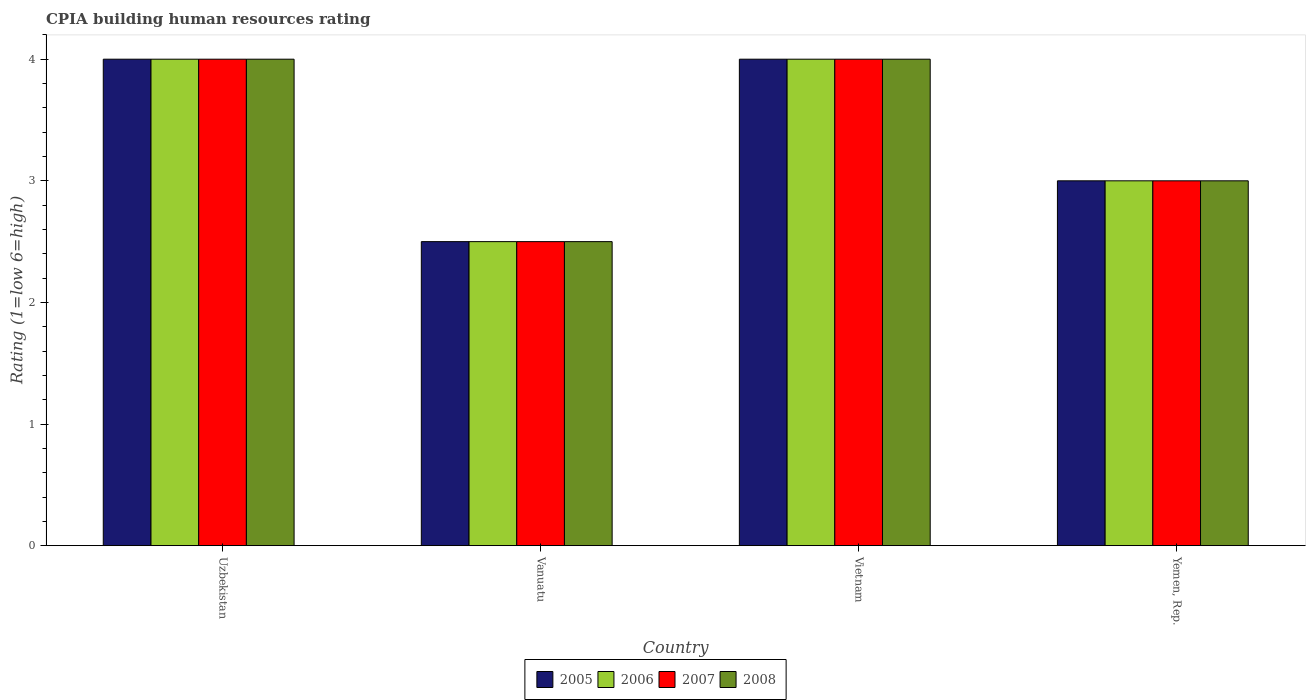Are the number of bars per tick equal to the number of legend labels?
Offer a terse response. Yes. How many bars are there on the 1st tick from the right?
Give a very brief answer. 4. What is the label of the 1st group of bars from the left?
Offer a very short reply. Uzbekistan. What is the CPIA rating in 2008 in Uzbekistan?
Your answer should be compact. 4. Across all countries, what is the maximum CPIA rating in 2007?
Ensure brevity in your answer.  4. In which country was the CPIA rating in 2008 maximum?
Provide a succinct answer. Uzbekistan. In which country was the CPIA rating in 2008 minimum?
Give a very brief answer. Vanuatu. What is the difference between the CPIA rating in 2007 in Vietnam and the CPIA rating in 2006 in Yemen, Rep.?
Provide a succinct answer. 1. What is the average CPIA rating in 2005 per country?
Ensure brevity in your answer.  3.38. What is the difference between the CPIA rating of/in 2008 and CPIA rating of/in 2006 in Vietnam?
Provide a short and direct response. 0. In how many countries, is the CPIA rating in 2007 greater than 2?
Your answer should be very brief. 4. Is the CPIA rating in 2006 in Uzbekistan less than that in Vietnam?
Offer a very short reply. No. What is the difference between the highest and the second highest CPIA rating in 2008?
Offer a terse response. -1. What is the difference between the highest and the lowest CPIA rating in 2006?
Ensure brevity in your answer.  1.5. Is the sum of the CPIA rating in 2006 in Vanuatu and Vietnam greater than the maximum CPIA rating in 2008 across all countries?
Offer a very short reply. Yes. Is it the case that in every country, the sum of the CPIA rating in 2005 and CPIA rating in 2007 is greater than the sum of CPIA rating in 2008 and CPIA rating in 2006?
Make the answer very short. No. What does the 3rd bar from the left in Vietnam represents?
Provide a short and direct response. 2007. Is it the case that in every country, the sum of the CPIA rating in 2005 and CPIA rating in 2007 is greater than the CPIA rating in 2006?
Offer a very short reply. Yes. How many bars are there?
Offer a terse response. 16. How many countries are there in the graph?
Keep it short and to the point. 4. What is the difference between two consecutive major ticks on the Y-axis?
Keep it short and to the point. 1. Are the values on the major ticks of Y-axis written in scientific E-notation?
Offer a very short reply. No. How many legend labels are there?
Give a very brief answer. 4. How are the legend labels stacked?
Your answer should be very brief. Horizontal. What is the title of the graph?
Ensure brevity in your answer.  CPIA building human resources rating. What is the Rating (1=low 6=high) in 2005 in Uzbekistan?
Make the answer very short. 4. What is the Rating (1=low 6=high) in 2006 in Vanuatu?
Provide a succinct answer. 2.5. What is the Rating (1=low 6=high) of 2005 in Vietnam?
Your answer should be very brief. 4. What is the Rating (1=low 6=high) of 2006 in Vietnam?
Your answer should be compact. 4. What is the Rating (1=low 6=high) in 2007 in Vietnam?
Keep it short and to the point. 4. What is the Rating (1=low 6=high) in 2005 in Yemen, Rep.?
Make the answer very short. 3. Across all countries, what is the maximum Rating (1=low 6=high) in 2005?
Your answer should be very brief. 4. Across all countries, what is the maximum Rating (1=low 6=high) in 2007?
Keep it short and to the point. 4. Across all countries, what is the maximum Rating (1=low 6=high) in 2008?
Your answer should be compact. 4. Across all countries, what is the minimum Rating (1=low 6=high) of 2005?
Make the answer very short. 2.5. Across all countries, what is the minimum Rating (1=low 6=high) in 2006?
Keep it short and to the point. 2.5. Across all countries, what is the minimum Rating (1=low 6=high) in 2008?
Provide a short and direct response. 2.5. What is the total Rating (1=low 6=high) in 2006 in the graph?
Offer a terse response. 13.5. What is the total Rating (1=low 6=high) of 2008 in the graph?
Provide a short and direct response. 13.5. What is the difference between the Rating (1=low 6=high) of 2006 in Uzbekistan and that in Vanuatu?
Give a very brief answer. 1.5. What is the difference between the Rating (1=low 6=high) in 2007 in Uzbekistan and that in Vanuatu?
Keep it short and to the point. 1.5. What is the difference between the Rating (1=low 6=high) of 2008 in Uzbekistan and that in Vanuatu?
Provide a short and direct response. 1.5. What is the difference between the Rating (1=low 6=high) in 2006 in Uzbekistan and that in Vietnam?
Offer a terse response. 0. What is the difference between the Rating (1=low 6=high) in 2008 in Uzbekistan and that in Vietnam?
Give a very brief answer. 0. What is the difference between the Rating (1=low 6=high) in 2005 in Uzbekistan and that in Yemen, Rep.?
Make the answer very short. 1. What is the difference between the Rating (1=low 6=high) of 2006 in Uzbekistan and that in Yemen, Rep.?
Offer a terse response. 1. What is the difference between the Rating (1=low 6=high) in 2008 in Uzbekistan and that in Yemen, Rep.?
Offer a terse response. 1. What is the difference between the Rating (1=low 6=high) in 2005 in Vanuatu and that in Vietnam?
Offer a very short reply. -1.5. What is the difference between the Rating (1=low 6=high) in 2007 in Vanuatu and that in Vietnam?
Ensure brevity in your answer.  -1.5. What is the difference between the Rating (1=low 6=high) of 2005 in Vanuatu and that in Yemen, Rep.?
Ensure brevity in your answer.  -0.5. What is the difference between the Rating (1=low 6=high) of 2006 in Vanuatu and that in Yemen, Rep.?
Offer a terse response. -0.5. What is the difference between the Rating (1=low 6=high) of 2008 in Vanuatu and that in Yemen, Rep.?
Offer a terse response. -0.5. What is the difference between the Rating (1=low 6=high) of 2005 in Vietnam and that in Yemen, Rep.?
Offer a terse response. 1. What is the difference between the Rating (1=low 6=high) in 2006 in Vietnam and that in Yemen, Rep.?
Provide a short and direct response. 1. What is the difference between the Rating (1=low 6=high) in 2005 in Uzbekistan and the Rating (1=low 6=high) in 2007 in Vanuatu?
Give a very brief answer. 1.5. What is the difference between the Rating (1=low 6=high) of 2005 in Uzbekistan and the Rating (1=low 6=high) of 2008 in Vanuatu?
Keep it short and to the point. 1.5. What is the difference between the Rating (1=low 6=high) of 2006 in Uzbekistan and the Rating (1=low 6=high) of 2007 in Vanuatu?
Provide a short and direct response. 1.5. What is the difference between the Rating (1=low 6=high) in 2007 in Uzbekistan and the Rating (1=low 6=high) in 2008 in Vanuatu?
Your answer should be very brief. 1.5. What is the difference between the Rating (1=low 6=high) of 2006 in Uzbekistan and the Rating (1=low 6=high) of 2008 in Vietnam?
Your answer should be very brief. 0. What is the difference between the Rating (1=low 6=high) of 2005 in Uzbekistan and the Rating (1=low 6=high) of 2007 in Yemen, Rep.?
Provide a succinct answer. 1. What is the difference between the Rating (1=low 6=high) in 2005 in Uzbekistan and the Rating (1=low 6=high) in 2008 in Yemen, Rep.?
Offer a terse response. 1. What is the difference between the Rating (1=low 6=high) in 2006 in Uzbekistan and the Rating (1=low 6=high) in 2008 in Yemen, Rep.?
Offer a terse response. 1. What is the difference between the Rating (1=low 6=high) of 2005 in Vanuatu and the Rating (1=low 6=high) of 2006 in Vietnam?
Keep it short and to the point. -1.5. What is the difference between the Rating (1=low 6=high) in 2005 in Vanuatu and the Rating (1=low 6=high) in 2007 in Vietnam?
Offer a very short reply. -1.5. What is the difference between the Rating (1=low 6=high) of 2005 in Vanuatu and the Rating (1=low 6=high) of 2006 in Yemen, Rep.?
Provide a succinct answer. -0.5. What is the difference between the Rating (1=low 6=high) in 2005 in Vanuatu and the Rating (1=low 6=high) in 2008 in Yemen, Rep.?
Provide a succinct answer. -0.5. What is the difference between the Rating (1=low 6=high) in 2006 in Vanuatu and the Rating (1=low 6=high) in 2007 in Yemen, Rep.?
Ensure brevity in your answer.  -0.5. What is the difference between the Rating (1=low 6=high) of 2005 in Vietnam and the Rating (1=low 6=high) of 2008 in Yemen, Rep.?
Keep it short and to the point. 1. What is the difference between the Rating (1=low 6=high) of 2006 in Vietnam and the Rating (1=low 6=high) of 2007 in Yemen, Rep.?
Offer a very short reply. 1. What is the difference between the Rating (1=low 6=high) in 2007 in Vietnam and the Rating (1=low 6=high) in 2008 in Yemen, Rep.?
Make the answer very short. 1. What is the average Rating (1=low 6=high) in 2005 per country?
Your response must be concise. 3.38. What is the average Rating (1=low 6=high) of 2006 per country?
Your answer should be very brief. 3.38. What is the average Rating (1=low 6=high) of 2007 per country?
Provide a succinct answer. 3.38. What is the average Rating (1=low 6=high) in 2008 per country?
Make the answer very short. 3.38. What is the difference between the Rating (1=low 6=high) in 2005 and Rating (1=low 6=high) in 2007 in Uzbekistan?
Your answer should be very brief. 0. What is the difference between the Rating (1=low 6=high) of 2006 and Rating (1=low 6=high) of 2007 in Uzbekistan?
Provide a short and direct response. 0. What is the difference between the Rating (1=low 6=high) in 2006 and Rating (1=low 6=high) in 2008 in Uzbekistan?
Offer a very short reply. 0. What is the difference between the Rating (1=low 6=high) of 2007 and Rating (1=low 6=high) of 2008 in Uzbekistan?
Ensure brevity in your answer.  0. What is the difference between the Rating (1=low 6=high) in 2005 and Rating (1=low 6=high) in 2008 in Vanuatu?
Your answer should be very brief. 0. What is the difference between the Rating (1=low 6=high) in 2007 and Rating (1=low 6=high) in 2008 in Vanuatu?
Your answer should be very brief. 0. What is the difference between the Rating (1=low 6=high) in 2005 and Rating (1=low 6=high) in 2006 in Vietnam?
Your answer should be compact. 0. What is the difference between the Rating (1=low 6=high) of 2005 and Rating (1=low 6=high) of 2008 in Vietnam?
Provide a succinct answer. 0. What is the difference between the Rating (1=low 6=high) in 2006 and Rating (1=low 6=high) in 2008 in Vietnam?
Offer a terse response. 0. What is the difference between the Rating (1=low 6=high) in 2007 and Rating (1=low 6=high) in 2008 in Vietnam?
Your response must be concise. 0. What is the difference between the Rating (1=low 6=high) of 2005 and Rating (1=low 6=high) of 2006 in Yemen, Rep.?
Your answer should be very brief. 0. What is the difference between the Rating (1=low 6=high) in 2005 and Rating (1=low 6=high) in 2008 in Yemen, Rep.?
Your answer should be compact. 0. What is the ratio of the Rating (1=low 6=high) of 2005 in Uzbekistan to that in Vietnam?
Give a very brief answer. 1. What is the ratio of the Rating (1=low 6=high) of 2008 in Uzbekistan to that in Vietnam?
Offer a terse response. 1. What is the ratio of the Rating (1=low 6=high) of 2008 in Uzbekistan to that in Yemen, Rep.?
Ensure brevity in your answer.  1.33. What is the ratio of the Rating (1=low 6=high) in 2007 in Vanuatu to that in Vietnam?
Your response must be concise. 0.62. What is the ratio of the Rating (1=low 6=high) in 2005 in Vanuatu to that in Yemen, Rep.?
Offer a very short reply. 0.83. What is the ratio of the Rating (1=low 6=high) of 2008 in Vanuatu to that in Yemen, Rep.?
Give a very brief answer. 0.83. What is the ratio of the Rating (1=low 6=high) of 2005 in Vietnam to that in Yemen, Rep.?
Offer a very short reply. 1.33. What is the difference between the highest and the second highest Rating (1=low 6=high) of 2006?
Your response must be concise. 0. What is the difference between the highest and the second highest Rating (1=low 6=high) in 2008?
Offer a terse response. 0. What is the difference between the highest and the lowest Rating (1=low 6=high) of 2008?
Offer a very short reply. 1.5. 